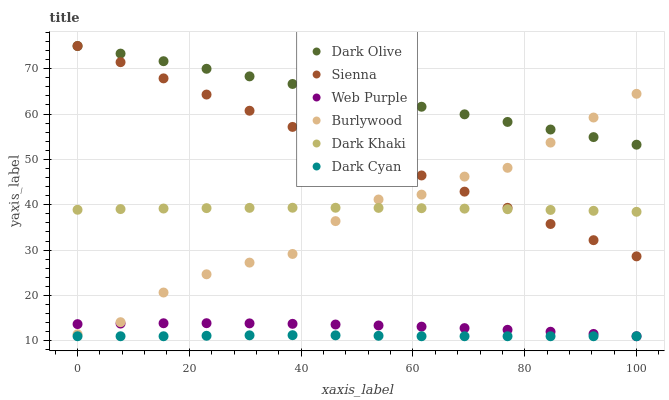Does Dark Cyan have the minimum area under the curve?
Answer yes or no. Yes. Does Dark Olive have the maximum area under the curve?
Answer yes or no. Yes. Does Burlywood have the minimum area under the curve?
Answer yes or no. No. Does Burlywood have the maximum area under the curve?
Answer yes or no. No. Is Sienna the smoothest?
Answer yes or no. Yes. Is Burlywood the roughest?
Answer yes or no. Yes. Is Dark Olive the smoothest?
Answer yes or no. No. Is Dark Olive the roughest?
Answer yes or no. No. Does Web Purple have the lowest value?
Answer yes or no. Yes. Does Burlywood have the lowest value?
Answer yes or no. No. Does Sienna have the highest value?
Answer yes or no. Yes. Does Burlywood have the highest value?
Answer yes or no. No. Is Web Purple less than Dark Khaki?
Answer yes or no. Yes. Is Dark Khaki greater than Web Purple?
Answer yes or no. Yes. Does Dark Olive intersect Sienna?
Answer yes or no. Yes. Is Dark Olive less than Sienna?
Answer yes or no. No. Is Dark Olive greater than Sienna?
Answer yes or no. No. Does Web Purple intersect Dark Khaki?
Answer yes or no. No. 